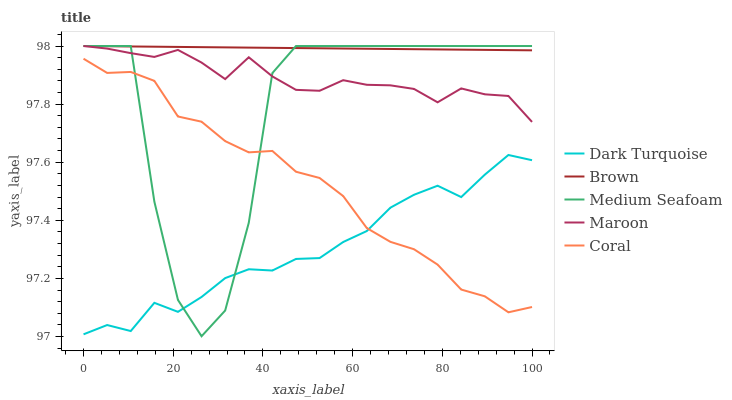Does Dark Turquoise have the minimum area under the curve?
Answer yes or no. Yes. Does Brown have the maximum area under the curve?
Answer yes or no. Yes. Does Coral have the minimum area under the curve?
Answer yes or no. No. Does Coral have the maximum area under the curve?
Answer yes or no. No. Is Brown the smoothest?
Answer yes or no. Yes. Is Medium Seafoam the roughest?
Answer yes or no. Yes. Is Coral the smoothest?
Answer yes or no. No. Is Coral the roughest?
Answer yes or no. No. Does Medium Seafoam have the lowest value?
Answer yes or no. Yes. Does Coral have the lowest value?
Answer yes or no. No. Does Brown have the highest value?
Answer yes or no. Yes. Does Coral have the highest value?
Answer yes or no. No. Is Coral less than Maroon?
Answer yes or no. Yes. Is Maroon greater than Dark Turquoise?
Answer yes or no. Yes. Does Brown intersect Medium Seafoam?
Answer yes or no. Yes. Is Brown less than Medium Seafoam?
Answer yes or no. No. Is Brown greater than Medium Seafoam?
Answer yes or no. No. Does Coral intersect Maroon?
Answer yes or no. No. 